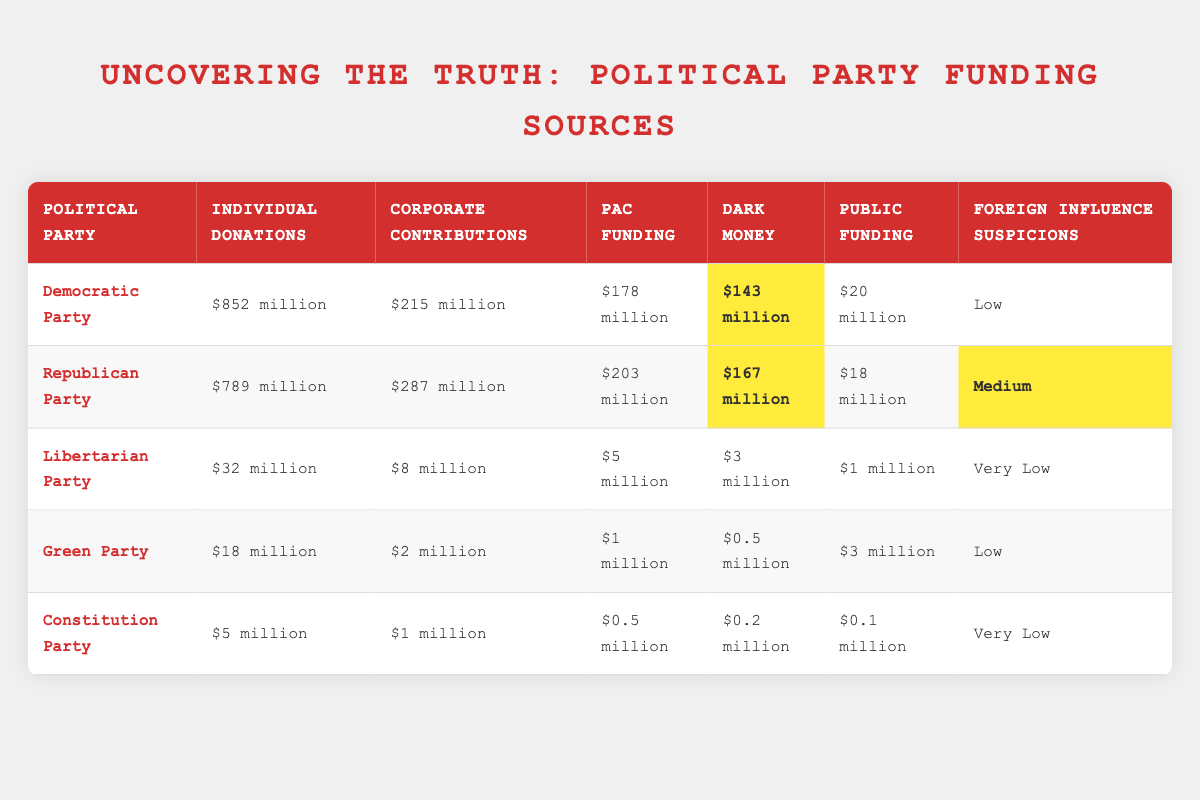What is the total amount of individual donations for the Democratic Party? According to the table, the Democratic Party received individual donations amounting to $852 million.
Answer: $852 million Which party received the highest amount in corporate contributions? The Republican Party received $287 million in corporate contributions, which is higher than any other party listed in the table.
Answer: Republican Party What is the difference in dark money between the Democratic Party and the Libertarian Party? The Democratic Party has $143 million in dark money, while the Libertarian Party has $3 million. The difference is $143 million - $3 million = $140 million.
Answer: $140 million Does the Green Party have more individual donations than the Constitution Party? The Green Party has $18 million in individual donations, while the Constitution Party has $5 million. Since $18 million is greater than $5 million, the statement is true.
Answer: Yes What is the average amount of PAC funding across all parties listed? Summing the PAC funding: $178 million (Democratic) + $203 million (Republican) + $5 million (Libertarian) + $1 million (Green) + $0.5 million (Constitution) = $387.5 million. There are 5 parties, so the average is $387.5 million / 5 = $77.5 million.
Answer: $77.5 million Which party has the lowest public funding, and what is the amount? From the table, the Constitution Party has the lowest public funding at $0.1 million, which is less than what the other parties received.
Answer: Constitution Party, $0.1 million Is there any party that has foreign influence suspicions rated as "Very Low"? The Libertarian Party and the Constitution Party both have foreign influence suspicions rated as "Very Low" according to the table.
Answer: Yes Which party has the combined highest total from Individual Donations, Corporate Contributions, and PAC Funding? For the Democratic Party, the total is $852 million (Individual) + $215 million (Corporate) + $178 million (PAC) = $1245 million. For the Republican Party, it is $789 million + $287 million + $203 million = $1279 million. The Republican Party has the highest total.
Answer: Republican Party, $1279 million 